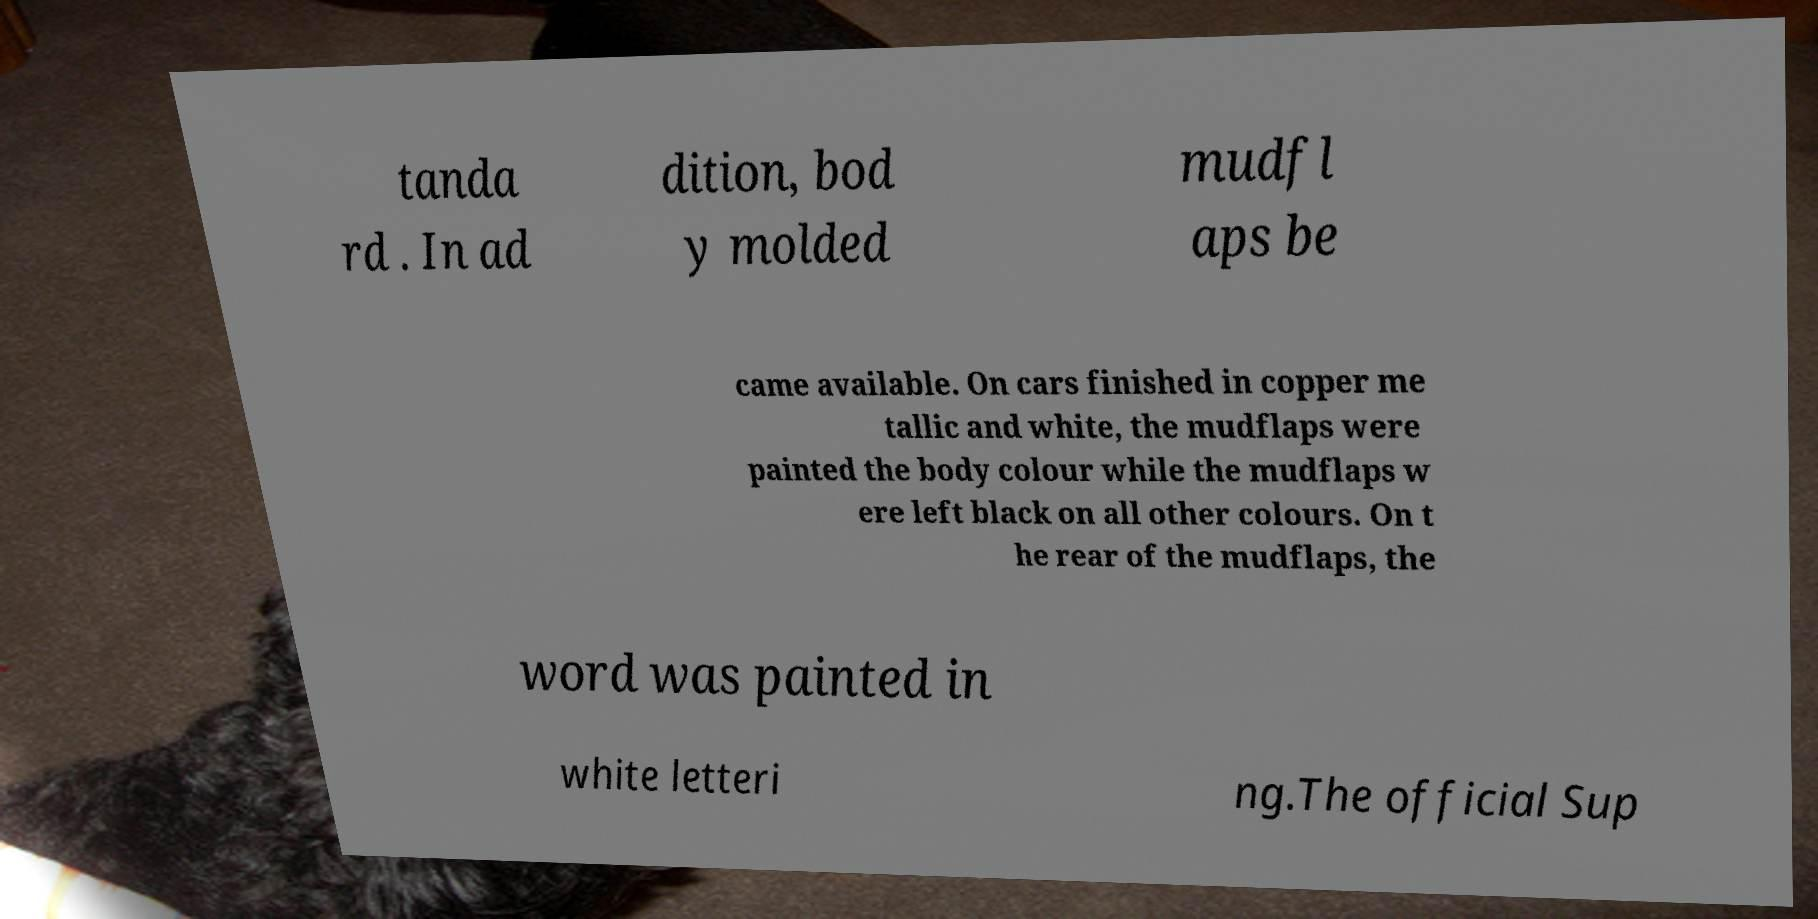Can you read and provide the text displayed in the image?This photo seems to have some interesting text. Can you extract and type it out for me? tanda rd . In ad dition, bod y molded mudfl aps be came available. On cars finished in copper me tallic and white, the mudflaps were painted the body colour while the mudflaps w ere left black on all other colours. On t he rear of the mudflaps, the word was painted in white letteri ng.The official Sup 